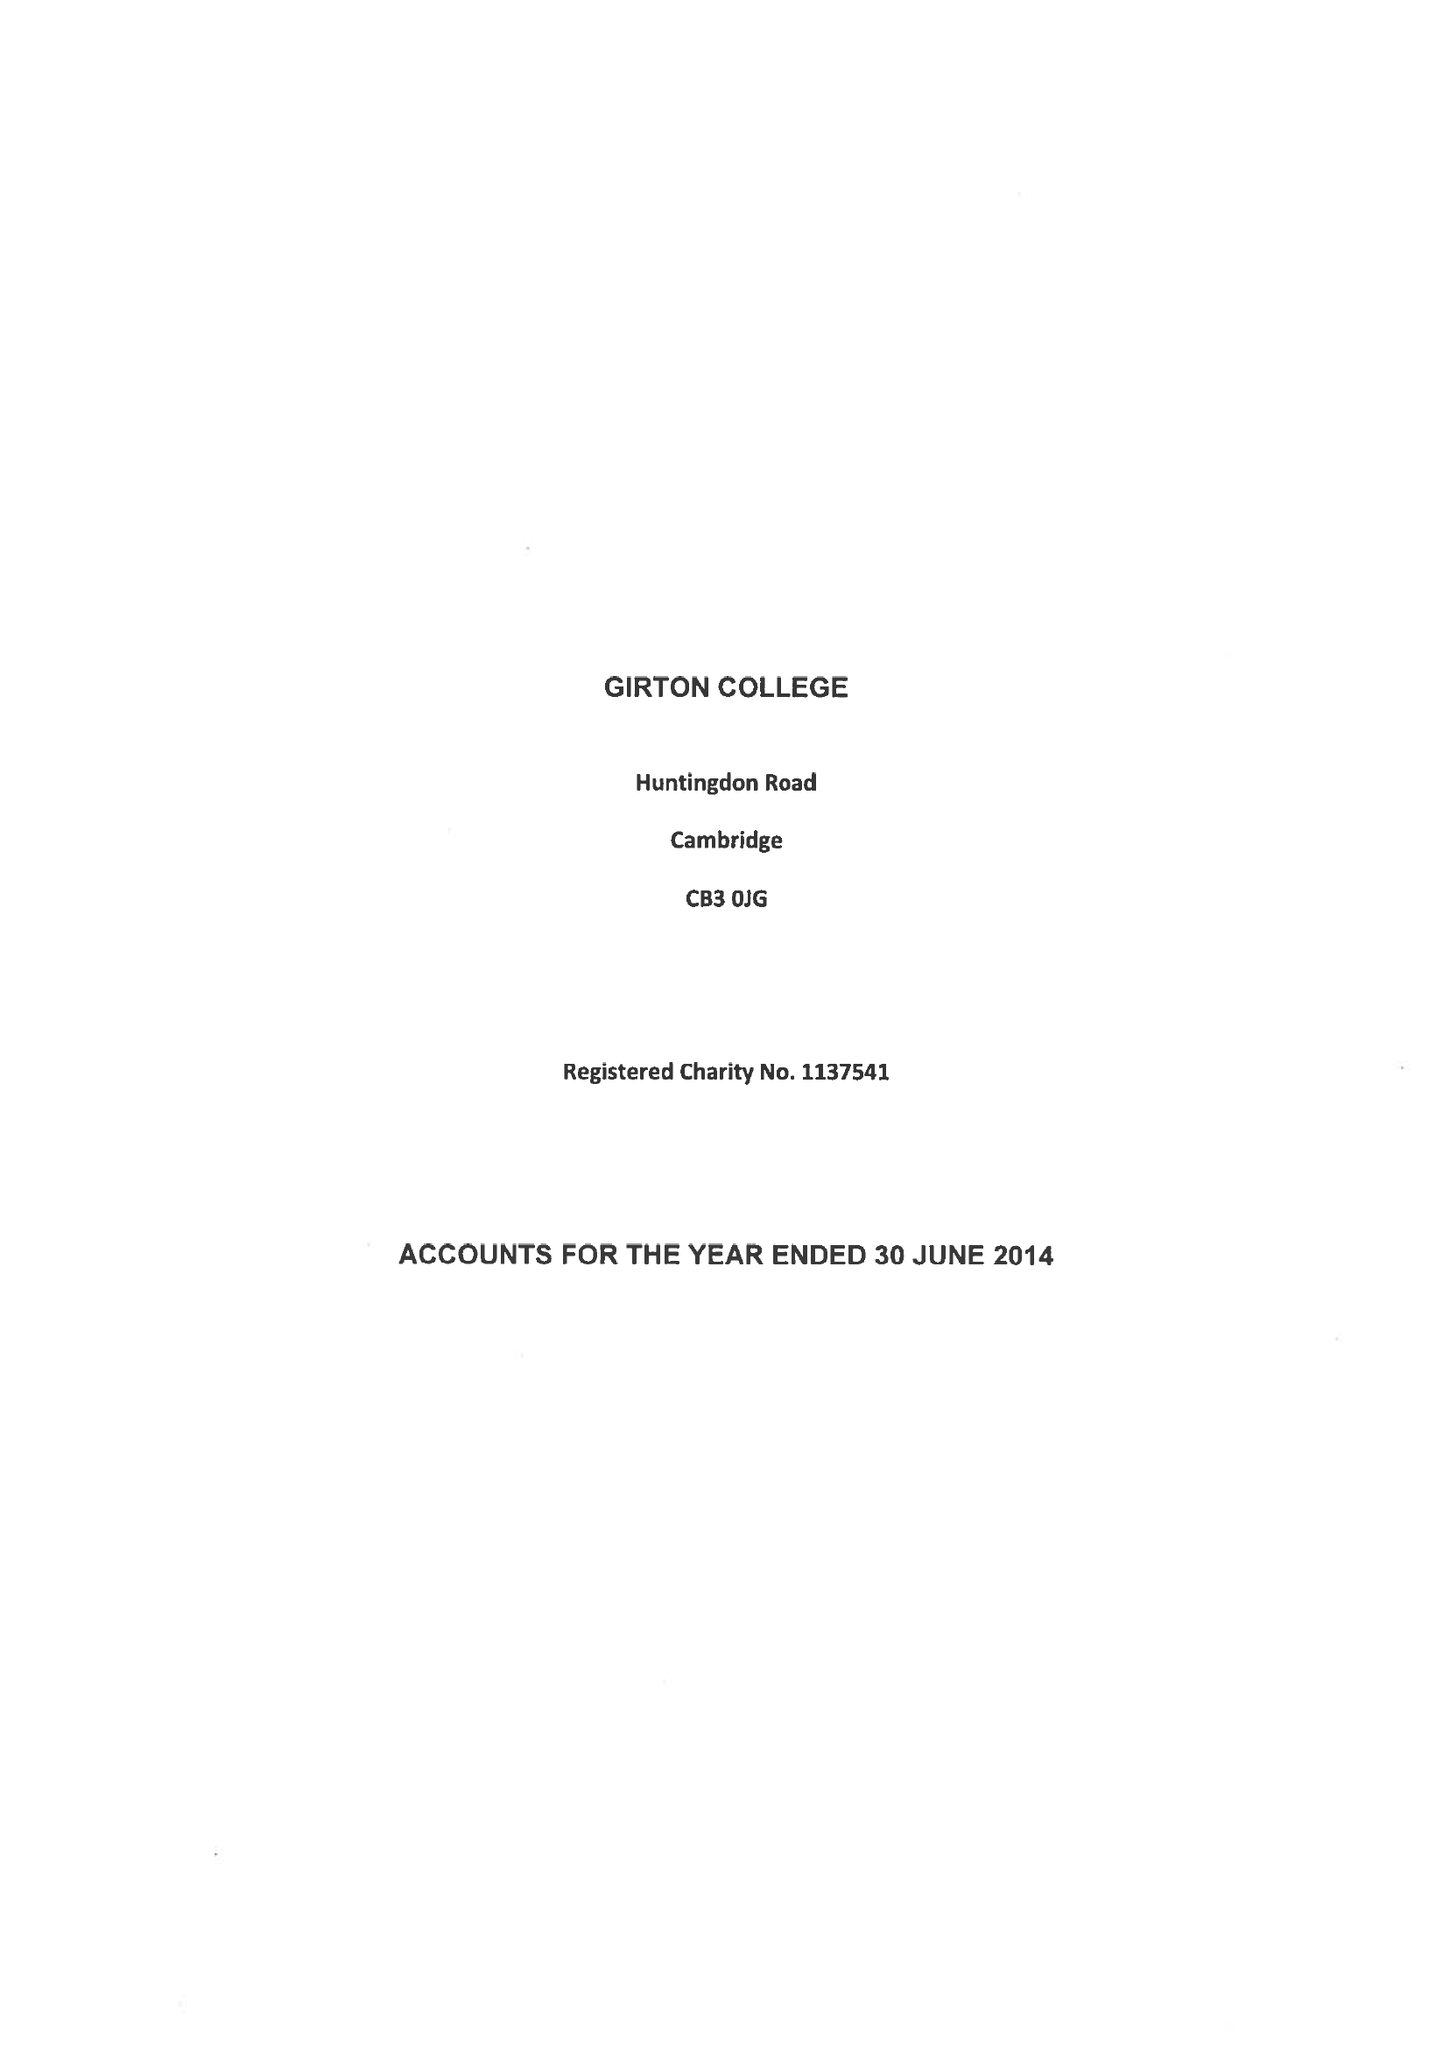What is the value for the address__street_line?
Answer the question using a single word or phrase. HUNTINGDON ROAD 